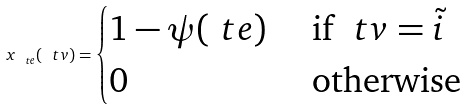<formula> <loc_0><loc_0><loc_500><loc_500>x _ { \ t e } ( \ t v ) = \begin{cases} 1 - \psi ( \ t e ) & \text { if } \ t v = \tilde { i } \\ 0 & \text { otherwise} \end{cases}</formula> 